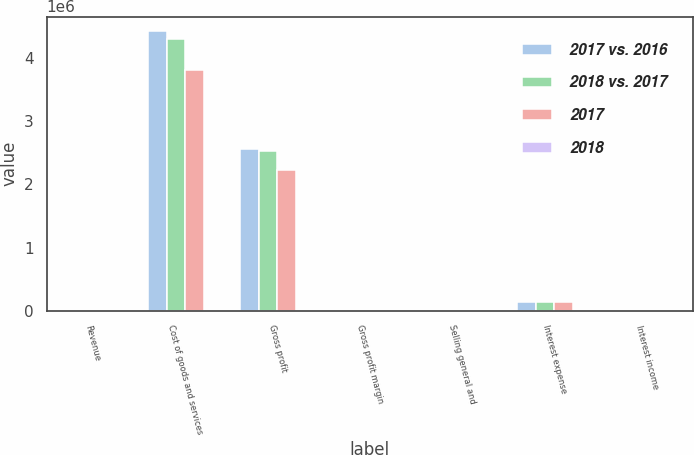<chart> <loc_0><loc_0><loc_500><loc_500><stacked_bar_chart><ecel><fcel>Revenue<fcel>Cost of goods and services<fcel>Gross profit<fcel>Gross profit margin<fcel>Selling general and<fcel>Interest expense<fcel>Interest income<nl><fcel>2017 vs. 2016<fcel>6752<fcel>4.43256e+06<fcel>2.55956e+06<fcel>36.6<fcel>24.5<fcel>130972<fcel>8881<nl><fcel>2018 vs. 2017<fcel>6752<fcel>4.29184e+06<fcel>2.52905e+06<fcel>37.1<fcel>25.2<fcel>144948<fcel>8491<nl><fcel>2017<fcel>6752<fcel>3.81567e+06<fcel>2.22755e+06<fcel>36.9<fcel>25.1<fcel>135969<fcel>6752<nl><fcel>2018<fcel>2.5<fcel>3.3<fcel>1.2<fcel>0.5<fcel>0.7<fcel>9.6<fcel>4.6<nl></chart> 